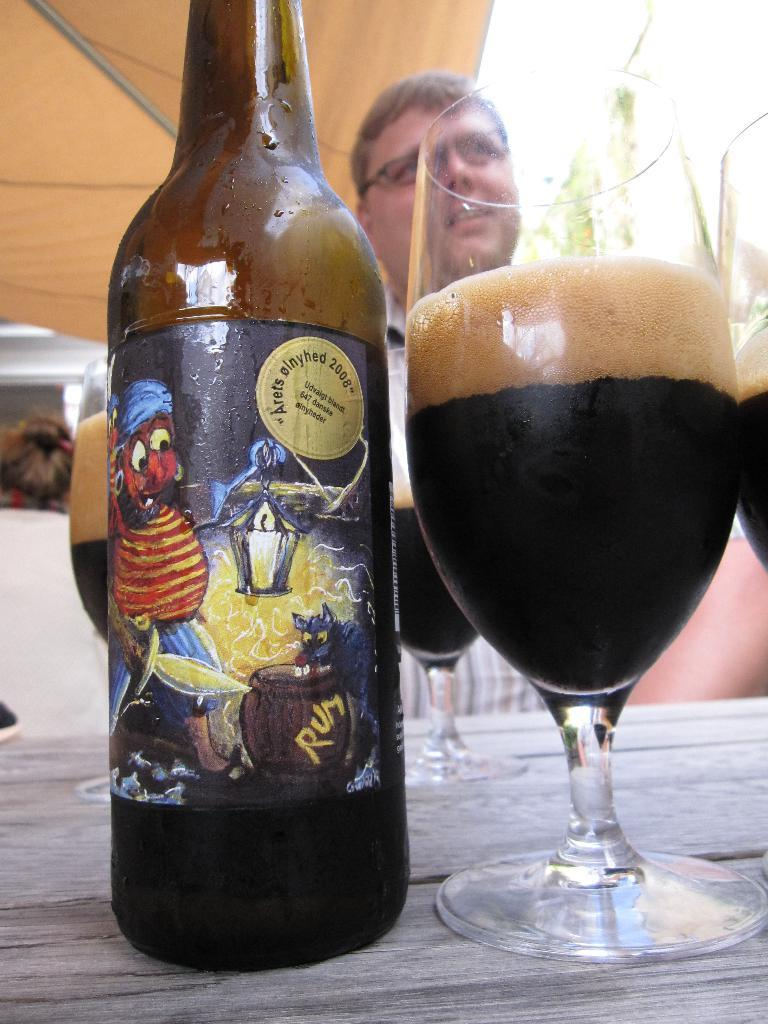What is on the table in the image? There is a wine bottle and a glass with a drink on the table. What is the man in the background of the image doing? The man is sitting in front of the table. How can you describe the man's appearance? The man is wearing spectacles. Does the man in the image have a cough? There is no indication of the man having a cough in the image. What type of scarf is the man wearing in the image? The man is not wearing a scarf in the image. 